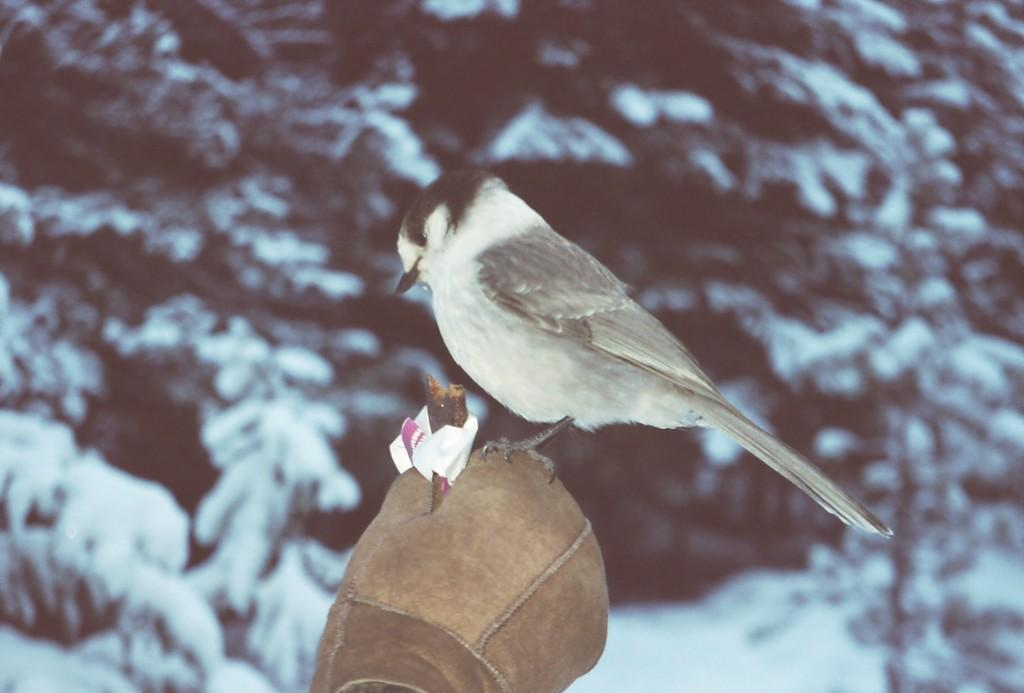What type of animal is in the image? There is a bird in the image. What is the bird sitting on? The bird is sitting on a glove. What can be seen in the background of the image? There are trees in the image. What is the condition of the trees in the image? Snow is present on the trees. How many rabbits are playing with a pipe in the image? There are no rabbits or pipes present in the image. What type of attraction is visible in the image? There is no attraction visible in the image; it features a bird sitting on a glove with snowy trees in the background. 